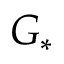<formula> <loc_0><loc_0><loc_500><loc_500>G _ { * }</formula> 